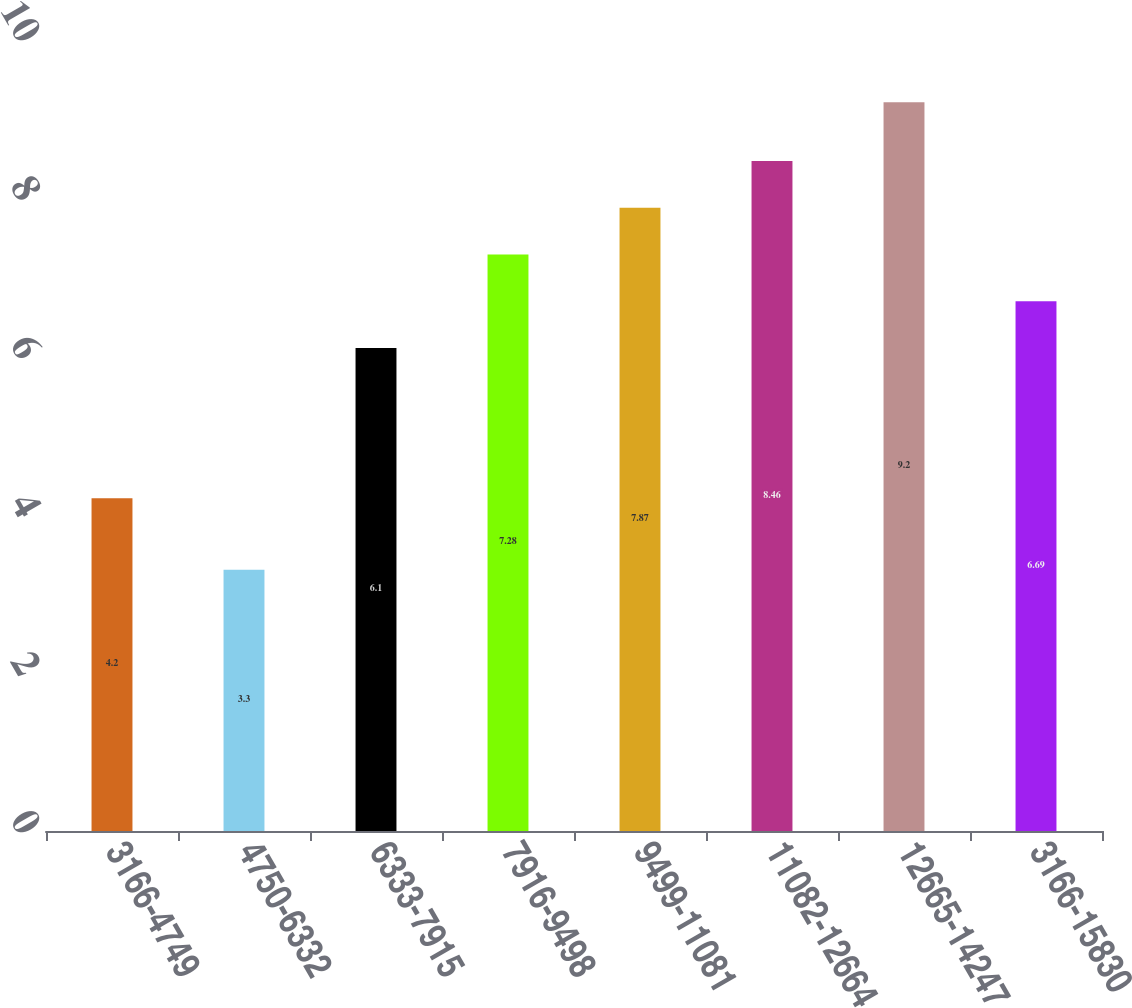<chart> <loc_0><loc_0><loc_500><loc_500><bar_chart><fcel>3166-4749<fcel>4750-6332<fcel>6333-7915<fcel>7916-9498<fcel>9499-11081<fcel>11082-12664<fcel>12665-14247<fcel>3166-15830<nl><fcel>4.2<fcel>3.3<fcel>6.1<fcel>7.28<fcel>7.87<fcel>8.46<fcel>9.2<fcel>6.69<nl></chart> 